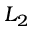<formula> <loc_0><loc_0><loc_500><loc_500>L _ { 2 }</formula> 